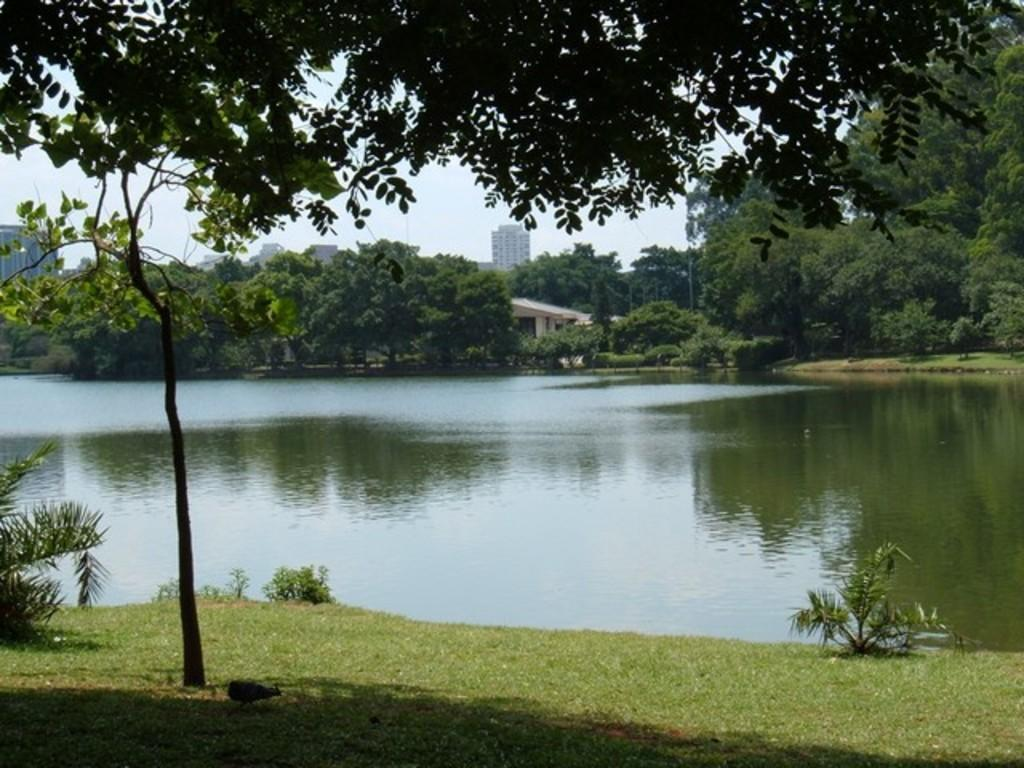What type of vegetation is present in the image? There is grass and plants in the image. What other natural elements can be seen in the image? There is a tree and water visible in the image. What is visible in the background of the image? There are trees, buildings, and the sky visible in the background of the image. What type of root can be seen growing in the water in the image? There is no root visible in the water in the image. How does the ocean contribute to the harmony of the scene in the image? There is no ocean present in the image; it features water, but not an ocean. 